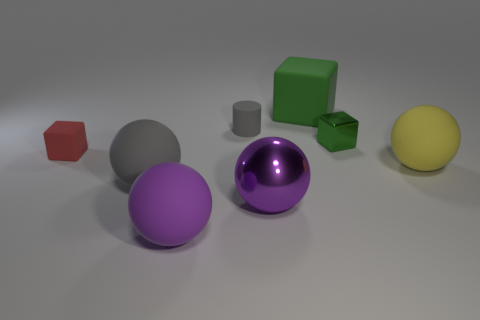There is a matte ball that is the same color as the big metallic ball; what is its size?
Keep it short and to the point. Large. Does the big matte block have the same color as the metal thing behind the big gray object?
Your answer should be very brief. Yes. What number of other things are the same color as the small metal object?
Make the answer very short. 1. What number of cylinders are large gray objects or small green metallic objects?
Provide a short and direct response. 0. What color is the matte block behind the red block?
Give a very brief answer. Green. What is the shape of the green metallic thing that is the same size as the cylinder?
Offer a terse response. Cube. There is a small rubber cube; what number of large objects are on the left side of it?
Offer a very short reply. 0. What number of things are gray cylinders or blue metallic things?
Offer a terse response. 1. What is the shape of the rubber object that is both to the left of the purple shiny sphere and behind the tiny metal thing?
Make the answer very short. Cylinder. What number of large balls are there?
Your response must be concise. 4. 